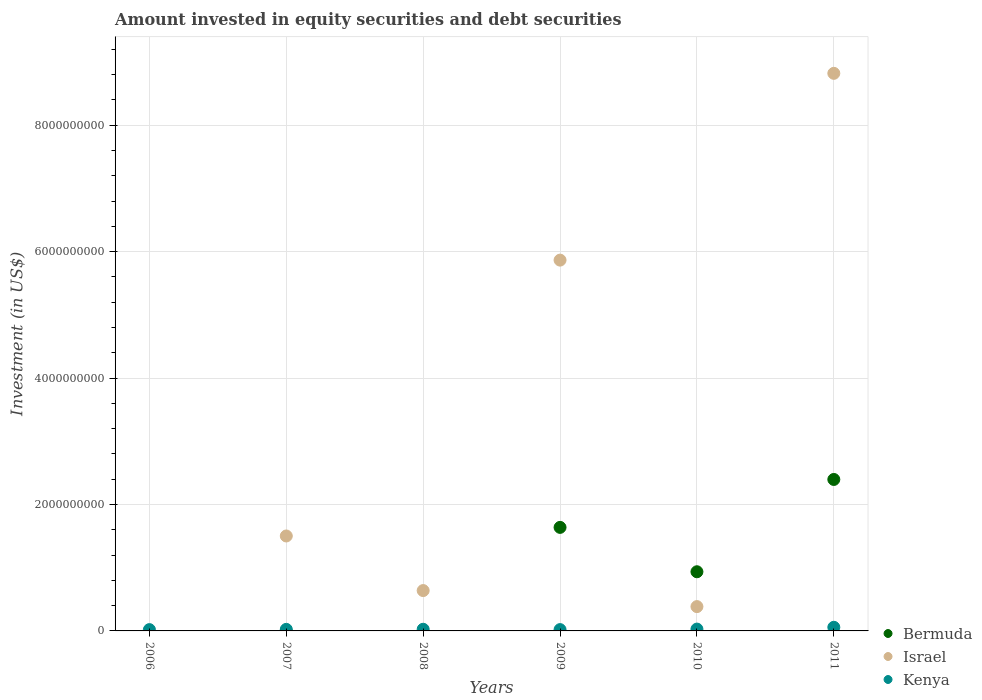How many different coloured dotlines are there?
Provide a short and direct response. 3. What is the amount invested in equity securities and debt securities in Kenya in 2010?
Offer a very short reply. 2.90e+07. Across all years, what is the maximum amount invested in equity securities and debt securities in Kenya?
Your answer should be compact. 5.74e+07. Across all years, what is the minimum amount invested in equity securities and debt securities in Kenya?
Provide a short and direct response. 2.06e+07. What is the total amount invested in equity securities and debt securities in Israel in the graph?
Your response must be concise. 1.72e+1. What is the difference between the amount invested in equity securities and debt securities in Kenya in 2007 and that in 2009?
Offer a terse response. 3.84e+06. What is the difference between the amount invested in equity securities and debt securities in Bermuda in 2006 and the amount invested in equity securities and debt securities in Kenya in 2007?
Ensure brevity in your answer.  -2.47e+07. What is the average amount invested in equity securities and debt securities in Kenya per year?
Give a very brief answer. 2.98e+07. In the year 2011, what is the difference between the amount invested in equity securities and debt securities in Kenya and amount invested in equity securities and debt securities in Bermuda?
Your answer should be very brief. -2.34e+09. What is the ratio of the amount invested in equity securities and debt securities in Kenya in 2006 to that in 2008?
Provide a succinct answer. 0.79. Is the difference between the amount invested in equity securities and debt securities in Kenya in 2009 and 2011 greater than the difference between the amount invested in equity securities and debt securities in Bermuda in 2009 and 2011?
Your answer should be compact. Yes. What is the difference between the highest and the second highest amount invested in equity securities and debt securities in Israel?
Make the answer very short. 2.95e+09. What is the difference between the highest and the lowest amount invested in equity securities and debt securities in Bermuda?
Your answer should be compact. 2.40e+09. Is the sum of the amount invested in equity securities and debt securities in Bermuda in 2009 and 2011 greater than the maximum amount invested in equity securities and debt securities in Israel across all years?
Your response must be concise. No. Does the amount invested in equity securities and debt securities in Israel monotonically increase over the years?
Keep it short and to the point. No. Is the amount invested in equity securities and debt securities in Israel strictly greater than the amount invested in equity securities and debt securities in Kenya over the years?
Your response must be concise. No. Is the amount invested in equity securities and debt securities in Israel strictly less than the amount invested in equity securities and debt securities in Kenya over the years?
Your answer should be compact. No. How many dotlines are there?
Offer a terse response. 3. Are the values on the major ticks of Y-axis written in scientific E-notation?
Your response must be concise. No. How many legend labels are there?
Make the answer very short. 3. How are the legend labels stacked?
Your answer should be very brief. Vertical. What is the title of the graph?
Make the answer very short. Amount invested in equity securities and debt securities. Does "Guatemala" appear as one of the legend labels in the graph?
Give a very brief answer. No. What is the label or title of the X-axis?
Your response must be concise. Years. What is the label or title of the Y-axis?
Provide a short and direct response. Investment (in US$). What is the Investment (in US$) in Israel in 2006?
Provide a succinct answer. 0. What is the Investment (in US$) of Kenya in 2006?
Ensure brevity in your answer.  2.06e+07. What is the Investment (in US$) in Israel in 2007?
Provide a succinct answer. 1.50e+09. What is the Investment (in US$) in Kenya in 2007?
Your response must be concise. 2.47e+07. What is the Investment (in US$) in Bermuda in 2008?
Your response must be concise. 0. What is the Investment (in US$) in Israel in 2008?
Ensure brevity in your answer.  6.38e+08. What is the Investment (in US$) in Kenya in 2008?
Your answer should be compact. 2.61e+07. What is the Investment (in US$) in Bermuda in 2009?
Give a very brief answer. 1.64e+09. What is the Investment (in US$) in Israel in 2009?
Provide a short and direct response. 5.86e+09. What is the Investment (in US$) of Kenya in 2009?
Offer a terse response. 2.09e+07. What is the Investment (in US$) in Bermuda in 2010?
Your answer should be very brief. 9.36e+08. What is the Investment (in US$) in Israel in 2010?
Keep it short and to the point. 3.85e+08. What is the Investment (in US$) in Kenya in 2010?
Ensure brevity in your answer.  2.90e+07. What is the Investment (in US$) in Bermuda in 2011?
Provide a short and direct response. 2.40e+09. What is the Investment (in US$) of Israel in 2011?
Offer a very short reply. 8.82e+09. What is the Investment (in US$) in Kenya in 2011?
Offer a terse response. 5.74e+07. Across all years, what is the maximum Investment (in US$) in Bermuda?
Offer a terse response. 2.40e+09. Across all years, what is the maximum Investment (in US$) in Israel?
Keep it short and to the point. 8.82e+09. Across all years, what is the maximum Investment (in US$) in Kenya?
Give a very brief answer. 5.74e+07. Across all years, what is the minimum Investment (in US$) of Bermuda?
Ensure brevity in your answer.  0. Across all years, what is the minimum Investment (in US$) in Kenya?
Keep it short and to the point. 2.06e+07. What is the total Investment (in US$) in Bermuda in the graph?
Make the answer very short. 4.97e+09. What is the total Investment (in US$) of Israel in the graph?
Keep it short and to the point. 1.72e+1. What is the total Investment (in US$) of Kenya in the graph?
Make the answer very short. 1.79e+08. What is the difference between the Investment (in US$) of Kenya in 2006 and that in 2007?
Offer a terse response. -4.10e+06. What is the difference between the Investment (in US$) of Kenya in 2006 and that in 2008?
Offer a terse response. -5.47e+06. What is the difference between the Investment (in US$) of Kenya in 2006 and that in 2009?
Your response must be concise. -2.59e+05. What is the difference between the Investment (in US$) of Kenya in 2006 and that in 2010?
Provide a succinct answer. -8.33e+06. What is the difference between the Investment (in US$) in Kenya in 2006 and that in 2011?
Your response must be concise. -3.67e+07. What is the difference between the Investment (in US$) of Israel in 2007 and that in 2008?
Ensure brevity in your answer.  8.63e+08. What is the difference between the Investment (in US$) in Kenya in 2007 and that in 2008?
Provide a short and direct response. -1.37e+06. What is the difference between the Investment (in US$) in Israel in 2007 and that in 2009?
Keep it short and to the point. -4.36e+09. What is the difference between the Investment (in US$) in Kenya in 2007 and that in 2009?
Your answer should be very brief. 3.84e+06. What is the difference between the Investment (in US$) in Israel in 2007 and that in 2010?
Your answer should be very brief. 1.12e+09. What is the difference between the Investment (in US$) in Kenya in 2007 and that in 2010?
Give a very brief answer. -4.23e+06. What is the difference between the Investment (in US$) in Israel in 2007 and that in 2011?
Your response must be concise. -7.32e+09. What is the difference between the Investment (in US$) of Kenya in 2007 and that in 2011?
Make the answer very short. -3.26e+07. What is the difference between the Investment (in US$) of Israel in 2008 and that in 2009?
Your answer should be compact. -5.23e+09. What is the difference between the Investment (in US$) in Kenya in 2008 and that in 2009?
Give a very brief answer. 5.21e+06. What is the difference between the Investment (in US$) of Israel in 2008 and that in 2010?
Make the answer very short. 2.54e+08. What is the difference between the Investment (in US$) of Kenya in 2008 and that in 2010?
Offer a very short reply. -2.86e+06. What is the difference between the Investment (in US$) of Israel in 2008 and that in 2011?
Provide a succinct answer. -8.18e+09. What is the difference between the Investment (in US$) of Kenya in 2008 and that in 2011?
Ensure brevity in your answer.  -3.13e+07. What is the difference between the Investment (in US$) in Bermuda in 2009 and that in 2010?
Give a very brief answer. 7.02e+08. What is the difference between the Investment (in US$) of Israel in 2009 and that in 2010?
Your answer should be very brief. 5.48e+09. What is the difference between the Investment (in US$) in Kenya in 2009 and that in 2010?
Ensure brevity in your answer.  -8.07e+06. What is the difference between the Investment (in US$) of Bermuda in 2009 and that in 2011?
Make the answer very short. -7.58e+08. What is the difference between the Investment (in US$) in Israel in 2009 and that in 2011?
Offer a very short reply. -2.95e+09. What is the difference between the Investment (in US$) in Kenya in 2009 and that in 2011?
Offer a terse response. -3.65e+07. What is the difference between the Investment (in US$) of Bermuda in 2010 and that in 2011?
Ensure brevity in your answer.  -1.46e+09. What is the difference between the Investment (in US$) of Israel in 2010 and that in 2011?
Offer a terse response. -8.43e+09. What is the difference between the Investment (in US$) in Kenya in 2010 and that in 2011?
Your answer should be compact. -2.84e+07. What is the difference between the Investment (in US$) of Israel in 2007 and the Investment (in US$) of Kenya in 2008?
Offer a terse response. 1.48e+09. What is the difference between the Investment (in US$) in Israel in 2007 and the Investment (in US$) in Kenya in 2009?
Your answer should be very brief. 1.48e+09. What is the difference between the Investment (in US$) in Israel in 2007 and the Investment (in US$) in Kenya in 2010?
Your answer should be compact. 1.47e+09. What is the difference between the Investment (in US$) of Israel in 2007 and the Investment (in US$) of Kenya in 2011?
Provide a short and direct response. 1.44e+09. What is the difference between the Investment (in US$) of Israel in 2008 and the Investment (in US$) of Kenya in 2009?
Provide a succinct answer. 6.17e+08. What is the difference between the Investment (in US$) of Israel in 2008 and the Investment (in US$) of Kenya in 2010?
Your response must be concise. 6.09e+08. What is the difference between the Investment (in US$) of Israel in 2008 and the Investment (in US$) of Kenya in 2011?
Keep it short and to the point. 5.81e+08. What is the difference between the Investment (in US$) in Bermuda in 2009 and the Investment (in US$) in Israel in 2010?
Ensure brevity in your answer.  1.25e+09. What is the difference between the Investment (in US$) in Bermuda in 2009 and the Investment (in US$) in Kenya in 2010?
Make the answer very short. 1.61e+09. What is the difference between the Investment (in US$) in Israel in 2009 and the Investment (in US$) in Kenya in 2010?
Provide a succinct answer. 5.84e+09. What is the difference between the Investment (in US$) in Bermuda in 2009 and the Investment (in US$) in Israel in 2011?
Provide a short and direct response. -7.18e+09. What is the difference between the Investment (in US$) of Bermuda in 2009 and the Investment (in US$) of Kenya in 2011?
Give a very brief answer. 1.58e+09. What is the difference between the Investment (in US$) of Israel in 2009 and the Investment (in US$) of Kenya in 2011?
Your response must be concise. 5.81e+09. What is the difference between the Investment (in US$) of Bermuda in 2010 and the Investment (in US$) of Israel in 2011?
Your answer should be very brief. -7.88e+09. What is the difference between the Investment (in US$) in Bermuda in 2010 and the Investment (in US$) in Kenya in 2011?
Make the answer very short. 8.78e+08. What is the difference between the Investment (in US$) in Israel in 2010 and the Investment (in US$) in Kenya in 2011?
Your answer should be compact. 3.27e+08. What is the average Investment (in US$) of Bermuda per year?
Keep it short and to the point. 8.28e+08. What is the average Investment (in US$) in Israel per year?
Give a very brief answer. 2.87e+09. What is the average Investment (in US$) of Kenya per year?
Offer a very short reply. 2.98e+07. In the year 2007, what is the difference between the Investment (in US$) in Israel and Investment (in US$) in Kenya?
Your response must be concise. 1.48e+09. In the year 2008, what is the difference between the Investment (in US$) of Israel and Investment (in US$) of Kenya?
Make the answer very short. 6.12e+08. In the year 2009, what is the difference between the Investment (in US$) in Bermuda and Investment (in US$) in Israel?
Provide a short and direct response. -4.23e+09. In the year 2009, what is the difference between the Investment (in US$) of Bermuda and Investment (in US$) of Kenya?
Offer a terse response. 1.62e+09. In the year 2009, what is the difference between the Investment (in US$) of Israel and Investment (in US$) of Kenya?
Provide a succinct answer. 5.84e+09. In the year 2010, what is the difference between the Investment (in US$) of Bermuda and Investment (in US$) of Israel?
Your response must be concise. 5.51e+08. In the year 2010, what is the difference between the Investment (in US$) in Bermuda and Investment (in US$) in Kenya?
Make the answer very short. 9.07e+08. In the year 2010, what is the difference between the Investment (in US$) of Israel and Investment (in US$) of Kenya?
Ensure brevity in your answer.  3.56e+08. In the year 2011, what is the difference between the Investment (in US$) in Bermuda and Investment (in US$) in Israel?
Offer a terse response. -6.42e+09. In the year 2011, what is the difference between the Investment (in US$) of Bermuda and Investment (in US$) of Kenya?
Offer a terse response. 2.34e+09. In the year 2011, what is the difference between the Investment (in US$) of Israel and Investment (in US$) of Kenya?
Provide a short and direct response. 8.76e+09. What is the ratio of the Investment (in US$) in Kenya in 2006 to that in 2007?
Offer a terse response. 0.83. What is the ratio of the Investment (in US$) of Kenya in 2006 to that in 2008?
Give a very brief answer. 0.79. What is the ratio of the Investment (in US$) in Kenya in 2006 to that in 2009?
Keep it short and to the point. 0.99. What is the ratio of the Investment (in US$) in Kenya in 2006 to that in 2010?
Give a very brief answer. 0.71. What is the ratio of the Investment (in US$) of Kenya in 2006 to that in 2011?
Give a very brief answer. 0.36. What is the ratio of the Investment (in US$) in Israel in 2007 to that in 2008?
Keep it short and to the point. 2.35. What is the ratio of the Investment (in US$) in Kenya in 2007 to that in 2008?
Keep it short and to the point. 0.95. What is the ratio of the Investment (in US$) in Israel in 2007 to that in 2009?
Give a very brief answer. 0.26. What is the ratio of the Investment (in US$) in Kenya in 2007 to that in 2009?
Make the answer very short. 1.18. What is the ratio of the Investment (in US$) in Israel in 2007 to that in 2010?
Provide a succinct answer. 3.9. What is the ratio of the Investment (in US$) of Kenya in 2007 to that in 2010?
Provide a succinct answer. 0.85. What is the ratio of the Investment (in US$) in Israel in 2007 to that in 2011?
Keep it short and to the point. 0.17. What is the ratio of the Investment (in US$) in Kenya in 2007 to that in 2011?
Your answer should be very brief. 0.43. What is the ratio of the Investment (in US$) in Israel in 2008 to that in 2009?
Your answer should be very brief. 0.11. What is the ratio of the Investment (in US$) in Kenya in 2008 to that in 2009?
Keep it short and to the point. 1.25. What is the ratio of the Investment (in US$) in Israel in 2008 to that in 2010?
Make the answer very short. 1.66. What is the ratio of the Investment (in US$) of Kenya in 2008 to that in 2010?
Your answer should be compact. 0.9. What is the ratio of the Investment (in US$) in Israel in 2008 to that in 2011?
Your answer should be compact. 0.07. What is the ratio of the Investment (in US$) of Kenya in 2008 to that in 2011?
Your answer should be very brief. 0.46. What is the ratio of the Investment (in US$) in Bermuda in 2009 to that in 2010?
Give a very brief answer. 1.75. What is the ratio of the Investment (in US$) in Israel in 2009 to that in 2010?
Offer a very short reply. 15.25. What is the ratio of the Investment (in US$) of Kenya in 2009 to that in 2010?
Offer a terse response. 0.72. What is the ratio of the Investment (in US$) in Bermuda in 2009 to that in 2011?
Offer a terse response. 0.68. What is the ratio of the Investment (in US$) in Israel in 2009 to that in 2011?
Offer a terse response. 0.67. What is the ratio of the Investment (in US$) of Kenya in 2009 to that in 2011?
Provide a short and direct response. 0.36. What is the ratio of the Investment (in US$) of Bermuda in 2010 to that in 2011?
Your answer should be compact. 0.39. What is the ratio of the Investment (in US$) of Israel in 2010 to that in 2011?
Ensure brevity in your answer.  0.04. What is the ratio of the Investment (in US$) of Kenya in 2010 to that in 2011?
Provide a short and direct response. 0.5. What is the difference between the highest and the second highest Investment (in US$) of Bermuda?
Your response must be concise. 7.58e+08. What is the difference between the highest and the second highest Investment (in US$) in Israel?
Your answer should be compact. 2.95e+09. What is the difference between the highest and the second highest Investment (in US$) in Kenya?
Provide a succinct answer. 2.84e+07. What is the difference between the highest and the lowest Investment (in US$) of Bermuda?
Provide a short and direct response. 2.40e+09. What is the difference between the highest and the lowest Investment (in US$) in Israel?
Offer a very short reply. 8.82e+09. What is the difference between the highest and the lowest Investment (in US$) of Kenya?
Offer a terse response. 3.67e+07. 